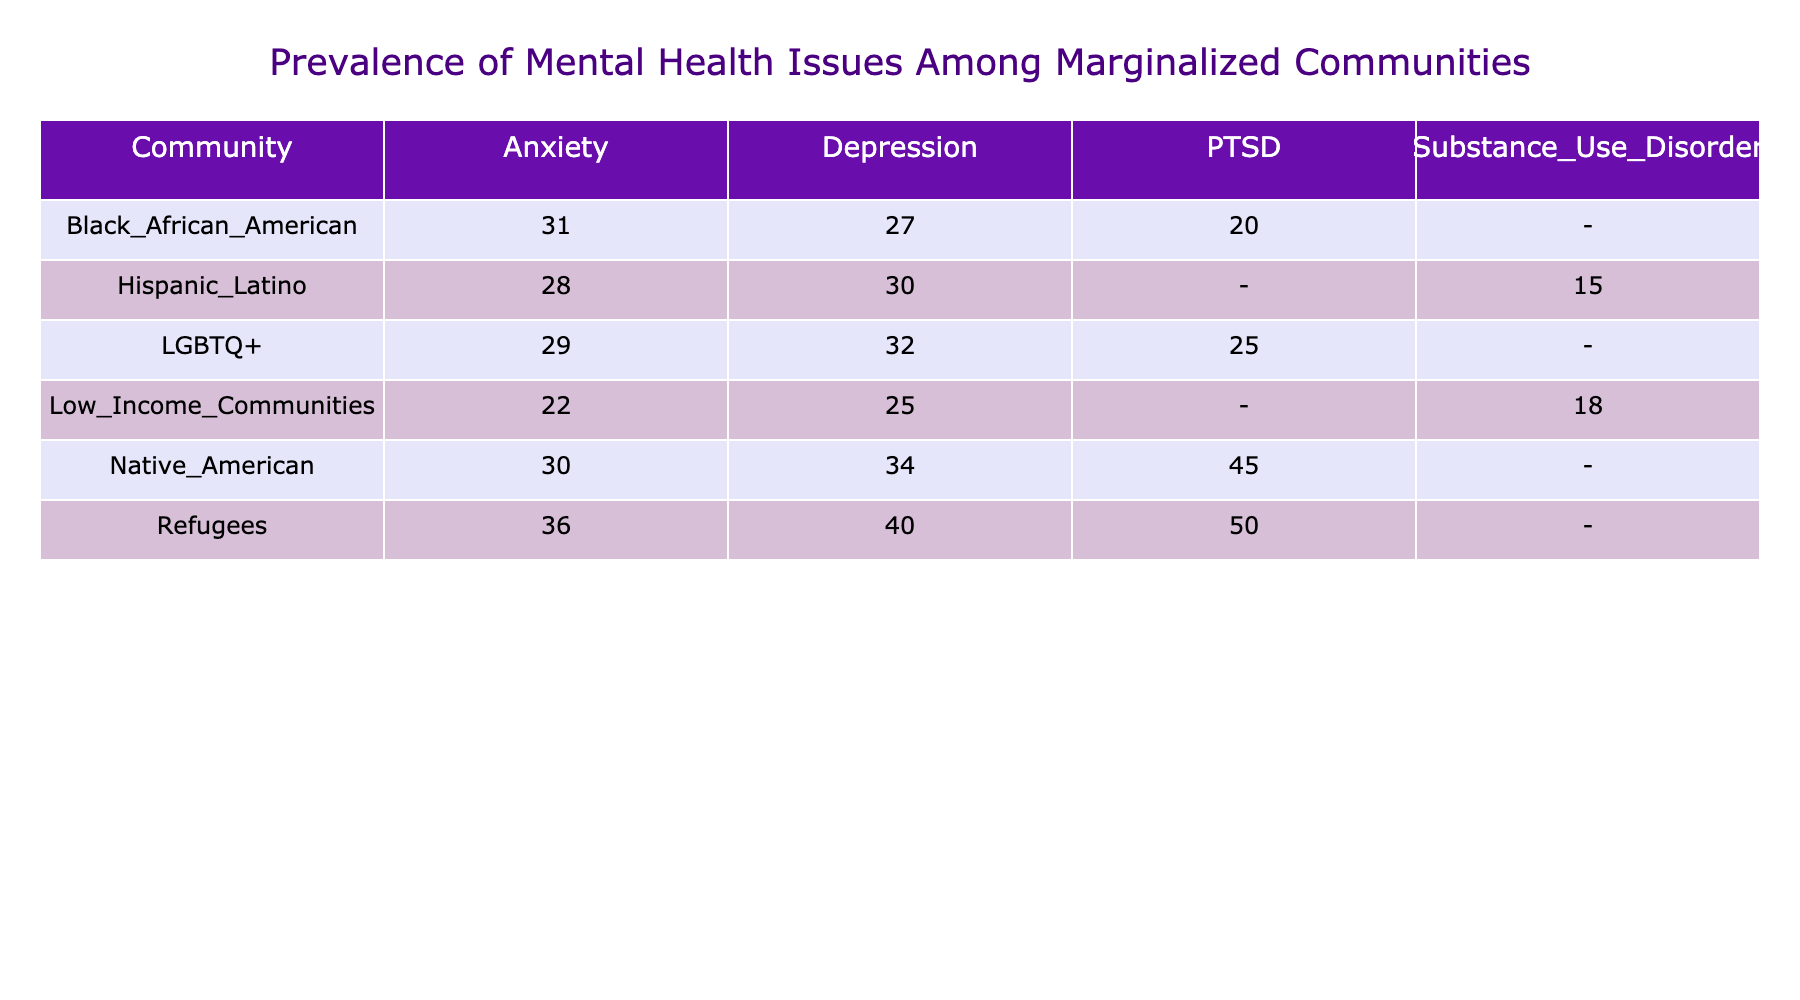What is the prevalence percentage of depression among Native American communities? According to the table, the prevalence percentage of depression for Native American communities is directly listed. It shows that the percentage is 34.
Answer: 34 Which community has the highest prevalence of PTSD? In the table, we look at the PTSD prevalence across all communities. The highest percentage is found in the Refugee community at 50.
Answer: 50 Is anxiety more prevalent among Black African American communities than Hispanic Latino communities? From the table, the prevalence percentage of anxiety for Black African American communities is 31, while for Hispanic Latino communities, it is 28. Thus, anxiety is indeed higher in Black African Americans.
Answer: Yes What is the average prevalence of depression across all communities listed in the table? To calculate the average, we find the sum of the prevalence percentages of depression: 32 (LGBTQ+) + 27 (Black African American) + 30 (Hispanic Latino) + 34 (Native American) + 40 (Refugees) + 25 (Low Income Communities) = 188. There are 6 communities, so we divide 188 by 6, which equals approximately 31.33.
Answer: 31.33 Do refugees have a higher prevalence of mental health issues overall compared to Low Income Communities? To determine this, we sum the prevalence percentages of all mental health issues for both groups. For Refugees: 40 (depression) + 36 (anxiety) + 50 (PTSD) = 126. For Low Income Communities: 25 (depression) + 22 (anxiety) + 18 (substance use disorder) = 65. Since 126 is greater than 65, refugees have a higher overall prevalence.
Answer: Yes 